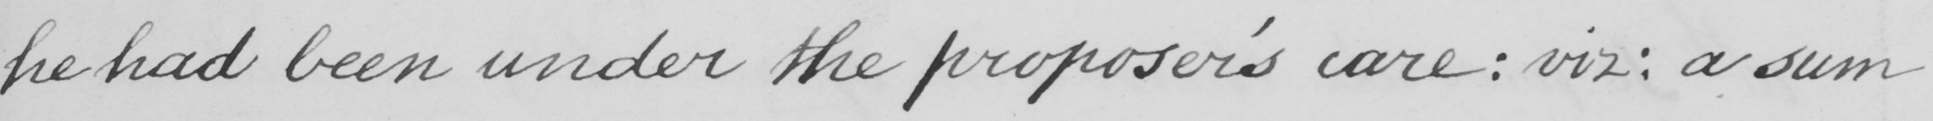Please provide the text content of this handwritten line. he had been under the proposer ' s care :  viz :  a sum 